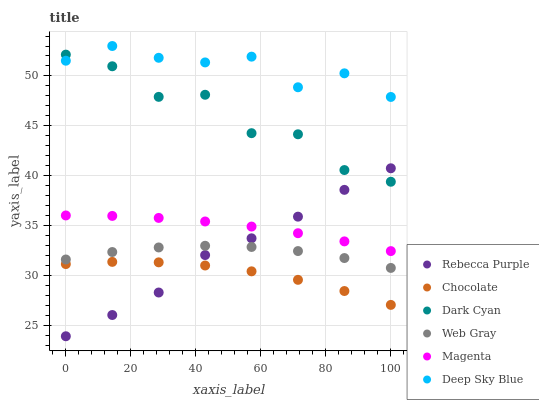Does Chocolate have the minimum area under the curve?
Answer yes or no. Yes. Does Deep Sky Blue have the maximum area under the curve?
Answer yes or no. Yes. Does Rebecca Purple have the minimum area under the curve?
Answer yes or no. No. Does Rebecca Purple have the maximum area under the curve?
Answer yes or no. No. Is Magenta the smoothest?
Answer yes or no. Yes. Is Dark Cyan the roughest?
Answer yes or no. Yes. Is Chocolate the smoothest?
Answer yes or no. No. Is Chocolate the roughest?
Answer yes or no. No. Does Rebecca Purple have the lowest value?
Answer yes or no. Yes. Does Chocolate have the lowest value?
Answer yes or no. No. Does Deep Sky Blue have the highest value?
Answer yes or no. Yes. Does Rebecca Purple have the highest value?
Answer yes or no. No. Is Chocolate less than Web Gray?
Answer yes or no. Yes. Is Dark Cyan greater than Web Gray?
Answer yes or no. Yes. Does Dark Cyan intersect Rebecca Purple?
Answer yes or no. Yes. Is Dark Cyan less than Rebecca Purple?
Answer yes or no. No. Is Dark Cyan greater than Rebecca Purple?
Answer yes or no. No. Does Chocolate intersect Web Gray?
Answer yes or no. No. 